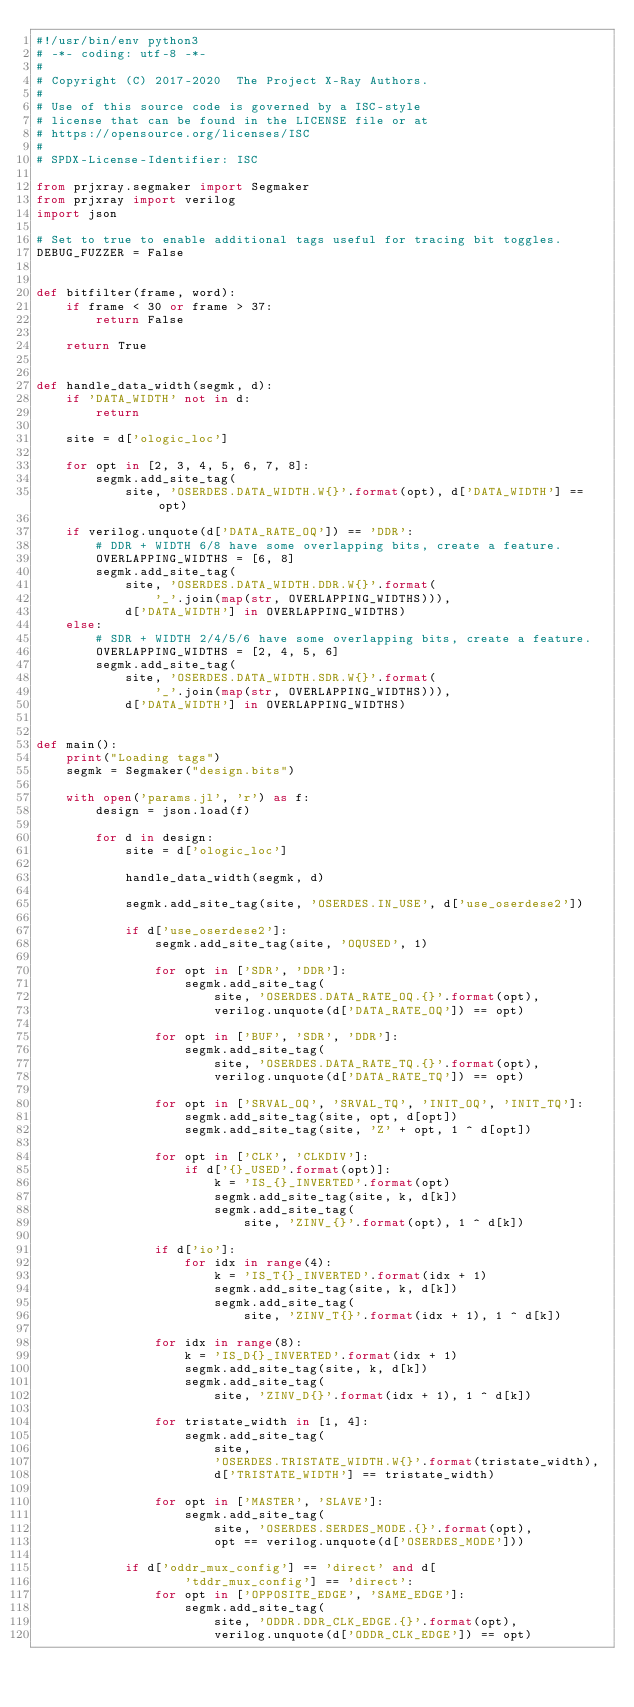Convert code to text. <code><loc_0><loc_0><loc_500><loc_500><_Python_>#!/usr/bin/env python3
# -*- coding: utf-8 -*-
#
# Copyright (C) 2017-2020  The Project X-Ray Authors.
#
# Use of this source code is governed by a ISC-style
# license that can be found in the LICENSE file or at
# https://opensource.org/licenses/ISC
#
# SPDX-License-Identifier: ISC

from prjxray.segmaker import Segmaker
from prjxray import verilog
import json

# Set to true to enable additional tags useful for tracing bit toggles.
DEBUG_FUZZER = False


def bitfilter(frame, word):
    if frame < 30 or frame > 37:
        return False

    return True


def handle_data_width(segmk, d):
    if 'DATA_WIDTH' not in d:
        return

    site = d['ologic_loc']

    for opt in [2, 3, 4, 5, 6, 7, 8]:
        segmk.add_site_tag(
            site, 'OSERDES.DATA_WIDTH.W{}'.format(opt), d['DATA_WIDTH'] == opt)

    if verilog.unquote(d['DATA_RATE_OQ']) == 'DDR':
        # DDR + WIDTH 6/8 have some overlapping bits, create a feature.
        OVERLAPPING_WIDTHS = [6, 8]
        segmk.add_site_tag(
            site, 'OSERDES.DATA_WIDTH.DDR.W{}'.format(
                '_'.join(map(str, OVERLAPPING_WIDTHS))),
            d['DATA_WIDTH'] in OVERLAPPING_WIDTHS)
    else:
        # SDR + WIDTH 2/4/5/6 have some overlapping bits, create a feature.
        OVERLAPPING_WIDTHS = [2, 4, 5, 6]
        segmk.add_site_tag(
            site, 'OSERDES.DATA_WIDTH.SDR.W{}'.format(
                '_'.join(map(str, OVERLAPPING_WIDTHS))),
            d['DATA_WIDTH'] in OVERLAPPING_WIDTHS)


def main():
    print("Loading tags")
    segmk = Segmaker("design.bits")

    with open('params.jl', 'r') as f:
        design = json.load(f)

        for d in design:
            site = d['ologic_loc']

            handle_data_width(segmk, d)

            segmk.add_site_tag(site, 'OSERDES.IN_USE', d['use_oserdese2'])

            if d['use_oserdese2']:
                segmk.add_site_tag(site, 'OQUSED', 1)

                for opt in ['SDR', 'DDR']:
                    segmk.add_site_tag(
                        site, 'OSERDES.DATA_RATE_OQ.{}'.format(opt),
                        verilog.unquote(d['DATA_RATE_OQ']) == opt)

                for opt in ['BUF', 'SDR', 'DDR']:
                    segmk.add_site_tag(
                        site, 'OSERDES.DATA_RATE_TQ.{}'.format(opt),
                        verilog.unquote(d['DATA_RATE_TQ']) == opt)

                for opt in ['SRVAL_OQ', 'SRVAL_TQ', 'INIT_OQ', 'INIT_TQ']:
                    segmk.add_site_tag(site, opt, d[opt])
                    segmk.add_site_tag(site, 'Z' + opt, 1 ^ d[opt])

                for opt in ['CLK', 'CLKDIV']:
                    if d['{}_USED'.format(opt)]:
                        k = 'IS_{}_INVERTED'.format(opt)
                        segmk.add_site_tag(site, k, d[k])
                        segmk.add_site_tag(
                            site, 'ZINV_{}'.format(opt), 1 ^ d[k])

                if d['io']:
                    for idx in range(4):
                        k = 'IS_T{}_INVERTED'.format(idx + 1)
                        segmk.add_site_tag(site, k, d[k])
                        segmk.add_site_tag(
                            site, 'ZINV_T{}'.format(idx + 1), 1 ^ d[k])

                for idx in range(8):
                    k = 'IS_D{}_INVERTED'.format(idx + 1)
                    segmk.add_site_tag(site, k, d[k])
                    segmk.add_site_tag(
                        site, 'ZINV_D{}'.format(idx + 1), 1 ^ d[k])

                for tristate_width in [1, 4]:
                    segmk.add_site_tag(
                        site,
                        'OSERDES.TRISTATE_WIDTH.W{}'.format(tristate_width),
                        d['TRISTATE_WIDTH'] == tristate_width)

                for opt in ['MASTER', 'SLAVE']:
                    segmk.add_site_tag(
                        site, 'OSERDES.SERDES_MODE.{}'.format(opt),
                        opt == verilog.unquote(d['OSERDES_MODE']))

            if d['oddr_mux_config'] == 'direct' and d[
                    'tddr_mux_config'] == 'direct':
                for opt in ['OPPOSITE_EDGE', 'SAME_EDGE']:
                    segmk.add_site_tag(
                        site, 'ODDR.DDR_CLK_EDGE.{}'.format(opt),
                        verilog.unquote(d['ODDR_CLK_EDGE']) == opt)
</code> 